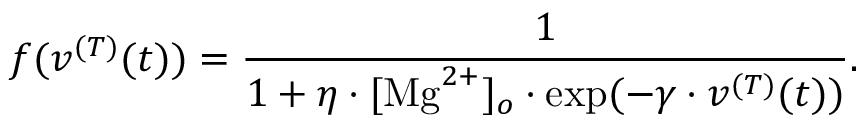Convert formula to latex. <formula><loc_0><loc_0><loc_500><loc_500>f ( v ^ { ( T ) } ( t ) ) = \frac { 1 } { 1 + \eta \cdot [ M g ^ { 2 + } ] _ { o } \cdot \exp ( - \gamma \cdot v ^ { ( T ) } ( t ) ) } .</formula> 